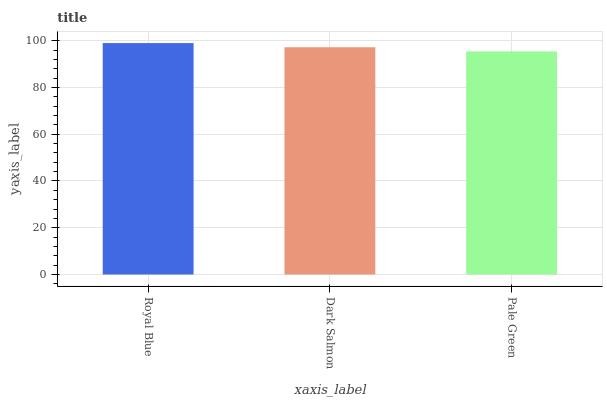Is Pale Green the minimum?
Answer yes or no. Yes. Is Royal Blue the maximum?
Answer yes or no. Yes. Is Dark Salmon the minimum?
Answer yes or no. No. Is Dark Salmon the maximum?
Answer yes or no. No. Is Royal Blue greater than Dark Salmon?
Answer yes or no. Yes. Is Dark Salmon less than Royal Blue?
Answer yes or no. Yes. Is Dark Salmon greater than Royal Blue?
Answer yes or no. No. Is Royal Blue less than Dark Salmon?
Answer yes or no. No. Is Dark Salmon the high median?
Answer yes or no. Yes. Is Dark Salmon the low median?
Answer yes or no. Yes. Is Royal Blue the high median?
Answer yes or no. No. Is Royal Blue the low median?
Answer yes or no. No. 